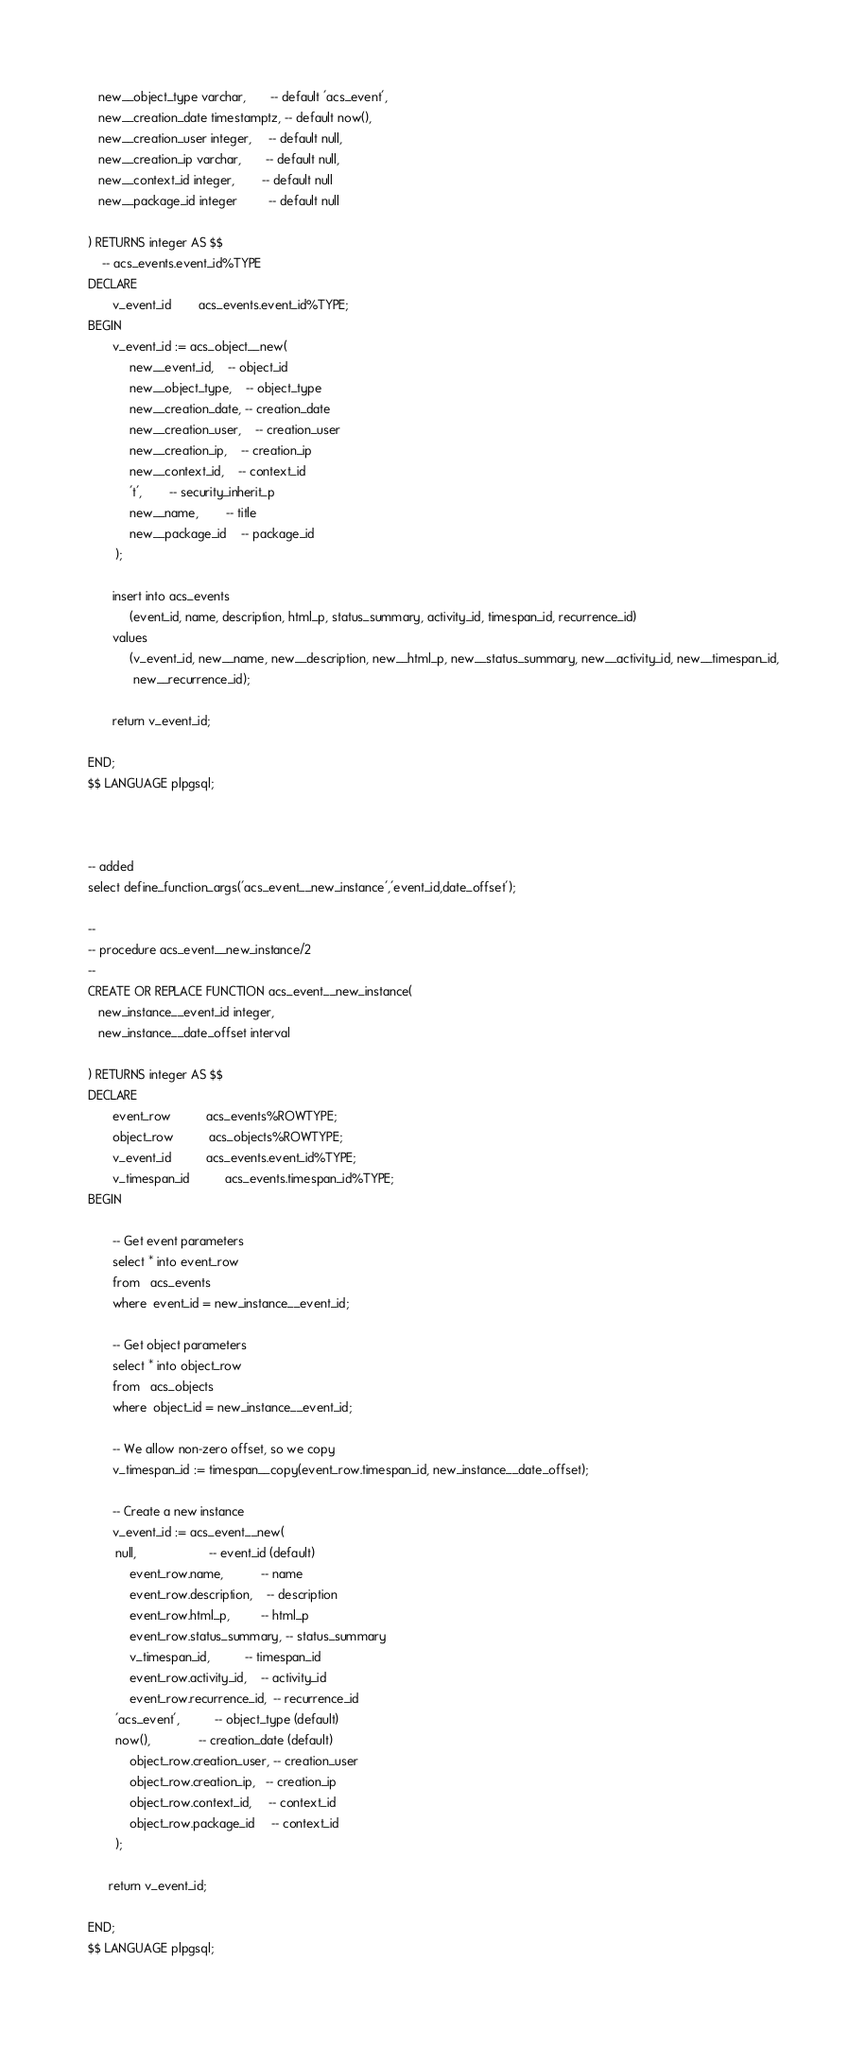Convert code to text. <code><loc_0><loc_0><loc_500><loc_500><_SQL_>   new__object_type varchar,       -- default 'acs_event',
   new__creation_date timestamptz, -- default now(),
   new__creation_user integer,     -- default null,
   new__creation_ip varchar,       -- default null,
   new__context_id integer,        -- default null
   new__package_id integer         -- default null

) RETURNS integer AS $$
	-- acs_events.event_id%TYPE
DECLARE
       v_event_id	    acs_events.event_id%TYPE;
BEGIN
       v_event_id := acs_object__new(
            new__event_id,	-- object_id
            new__object_type,	-- object_type
            new__creation_date, -- creation_date
            new__creation_user,	-- creation_user
            new__creation_ip,	-- creation_ip
            new__context_id,	-- context_id
            't',		-- security_inherit_p
            new__name,		-- title
            new__package_id	-- package_id
	    );

       insert into acs_events
            (event_id, name, description, html_p, status_summary, activity_id, timespan_id, recurrence_id)
       values
            (v_event_id, new__name, new__description, new__html_p, new__status_summary, new__activity_id, new__timespan_id,
             new__recurrence_id);

       return v_event_id;

END;
$$ LANGUAGE plpgsql;



-- added
select define_function_args('acs_event__new_instance','event_id,date_offset');

--
-- procedure acs_event__new_instance/2
--
CREATE OR REPLACE FUNCTION acs_event__new_instance(
   new_instance__event_id integer,
   new_instance__date_offset interval

) RETURNS integer AS $$
DECLARE
       event_row		  acs_events%ROWTYPE;
       object_row		  acs_objects%ROWTYPE;
       v_event_id		  acs_events.event_id%TYPE;
       v_timespan_id		  acs_events.timespan_id%TYPE;
BEGIN

       -- Get event parameters
       select * into event_row
       from   acs_events
       where  event_id = new_instance__event_id;

       -- Get object parameters                
       select * into object_row
       from   acs_objects
       where  object_id = new_instance__event_id;

       -- We allow non-zero offset, so we copy
       v_timespan_id := timespan__copy(event_row.timespan_id, new_instance__date_offset);

       -- Create a new instance
       v_event_id := acs_event__new(
	    null,                     -- event_id (default)
            event_row.name,           -- name
            event_row.description,    -- description
            event_row.html_p,         -- html_p
            event_row.status_summary, -- status_summary
            v_timespan_id,	      -- timespan_id
            event_row.activity_id,    -- activity_id
            event_row.recurrence_id,  -- recurrence_id
	    'acs_event',	      -- object_type (default)
	    now(),		      -- creation_date (default)
            object_row.creation_user, -- creation_user
            object_row.creation_ip,   -- creation_ip
            object_row.context_id,     -- context_id
            object_row.package_id     -- context_id
	    );

      return v_event_id;

END;
$$ LANGUAGE plpgsql;

</code> 